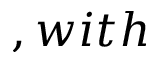<formula> <loc_0><loc_0><loc_500><loc_500>, w i t h</formula> 